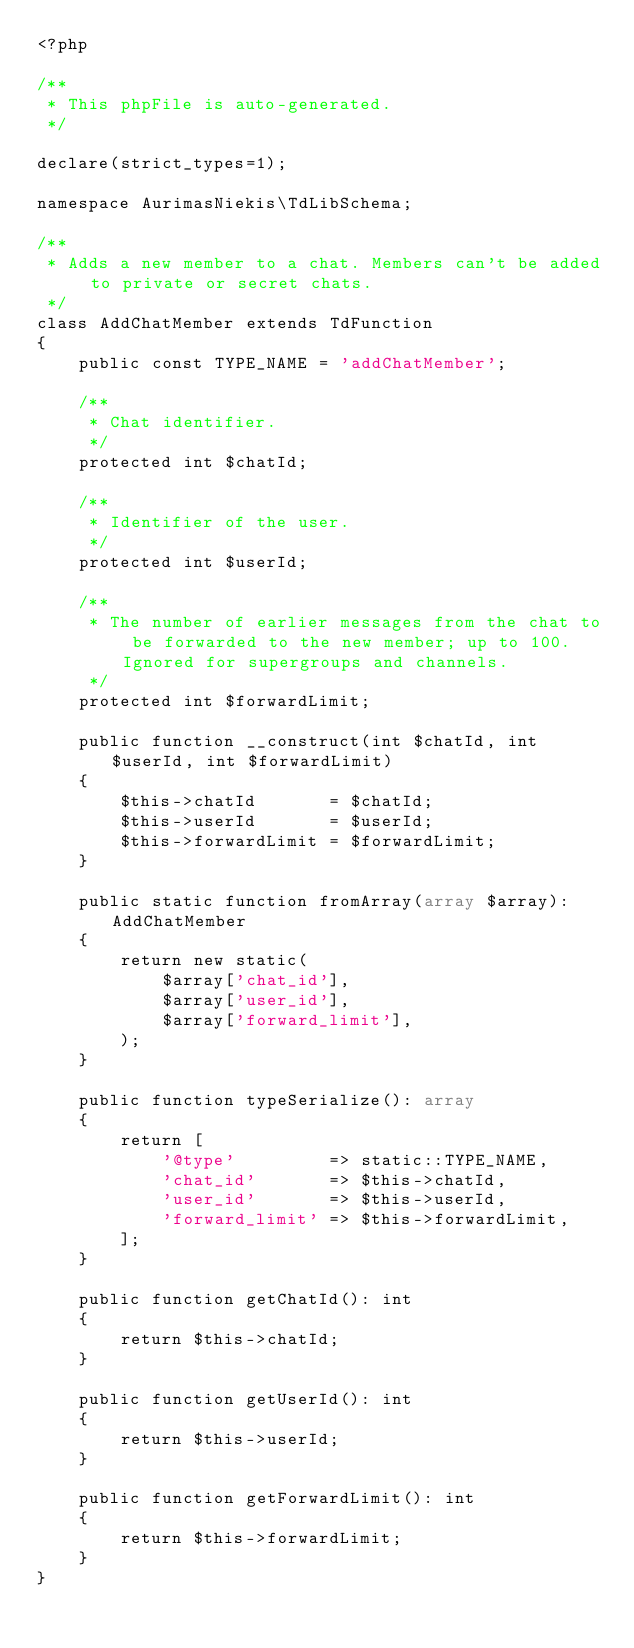Convert code to text. <code><loc_0><loc_0><loc_500><loc_500><_PHP_><?php

/**
 * This phpFile is auto-generated.
 */

declare(strict_types=1);

namespace AurimasNiekis\TdLibSchema;

/**
 * Adds a new member to a chat. Members can't be added to private or secret chats.
 */
class AddChatMember extends TdFunction
{
    public const TYPE_NAME = 'addChatMember';

    /**
     * Chat identifier.
     */
    protected int $chatId;

    /**
     * Identifier of the user.
     */
    protected int $userId;

    /**
     * The number of earlier messages from the chat to be forwarded to the new member; up to 100. Ignored for supergroups and channels.
     */
    protected int $forwardLimit;

    public function __construct(int $chatId, int $userId, int $forwardLimit)
    {
        $this->chatId       = $chatId;
        $this->userId       = $userId;
        $this->forwardLimit = $forwardLimit;
    }

    public static function fromArray(array $array): AddChatMember
    {
        return new static(
            $array['chat_id'],
            $array['user_id'],
            $array['forward_limit'],
        );
    }

    public function typeSerialize(): array
    {
        return [
            '@type'         => static::TYPE_NAME,
            'chat_id'       => $this->chatId,
            'user_id'       => $this->userId,
            'forward_limit' => $this->forwardLimit,
        ];
    }

    public function getChatId(): int
    {
        return $this->chatId;
    }

    public function getUserId(): int
    {
        return $this->userId;
    }

    public function getForwardLimit(): int
    {
        return $this->forwardLimit;
    }
}
</code> 